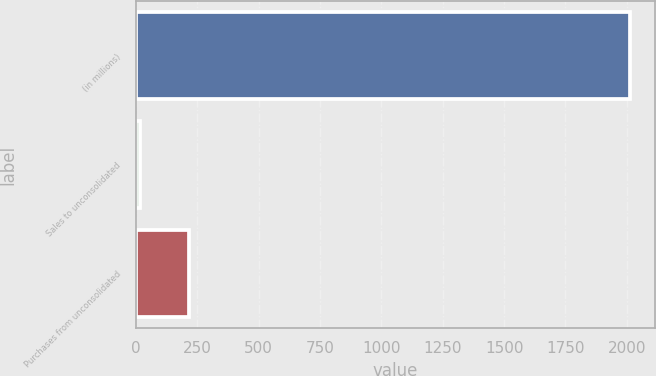<chart> <loc_0><loc_0><loc_500><loc_500><bar_chart><fcel>(in millions)<fcel>Sales to unconsolidated<fcel>Purchases from unconsolidated<nl><fcel>2014<fcel>16<fcel>215.8<nl></chart> 